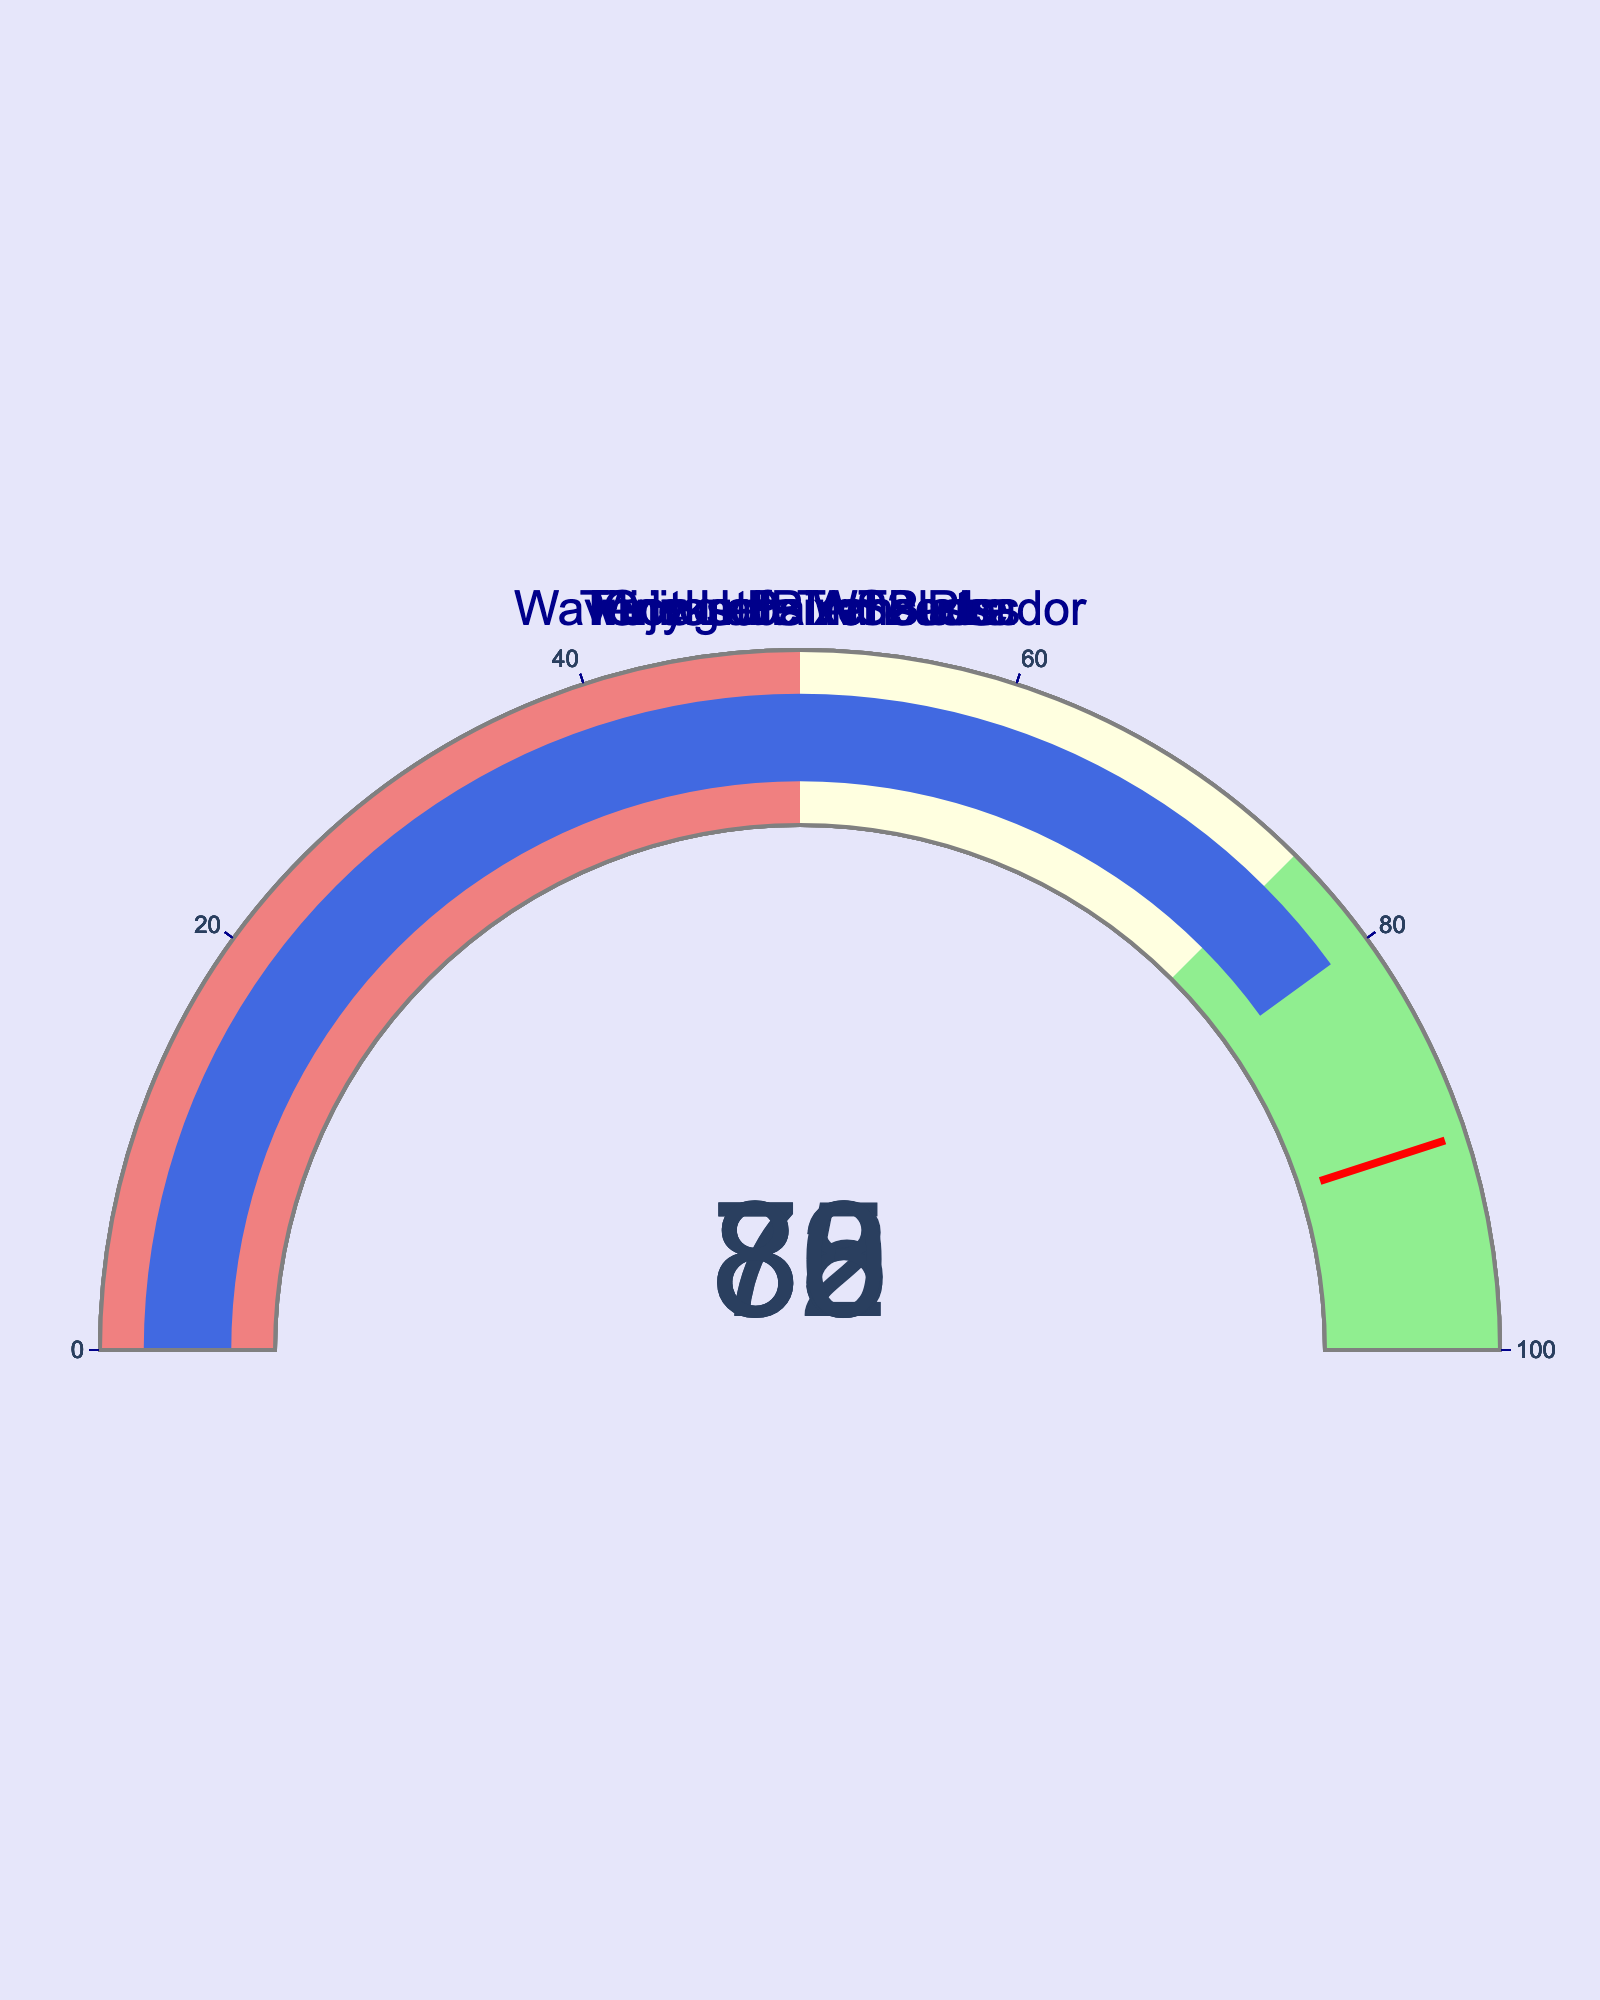How many devices are shown on the gauge charts? There are separate gauges displayed for each device's accuracy rate. By counting them, we find that there are five devices presented.
Answer: Five What is the accuracy rate of the Google Pixel Buds device? Look at the value displayed on the gauge chart for the Google Pixel Buds. The value reads 78.
Answer: 78 Which device shows the highest accuracy rate? Compare the values on all five gauge charts. The highest number is associated with the Fujitsu PalmSecure device, which has a rate of 85.
Answer: Fujitsu PalmSecure Which two devices have an accuracy rate that falls within the light green step range (75-100)? Identify the devices with accuracy values between 75 and 100. These values are highlighted by the light green step range on the gauge. Two devices meet this criterion: Fujitsu PalmSecure (85) and Microsoft Translator (82).
Answer: Fujitsu PalmSecure and Microsoft Translator What is the average accuracy rate of all the devices in the figure? Sum the accuracy rates of all the devices and then divide by the number of devices: (85 + 78 + 82 + 73 + 80) = 398. Dividing by 5 gives 398/5 = 79.6.
Answer: 79.6 What is the difference between the accuracy rates of the Timekettle WT2 Plus and the Waverly Labs Ambassador? Subtract the accuracy rate of Waverly Labs Ambassador (73) from the accuracy rate of Timekettle WT2 Plus (80). The calculation is 80 - 73 = 7.
Answer: 7 Which device has the lowest accuracy rate, and what is the value? Find the device with the smallest value on the gauge charts. The Waverly Labs Ambassador has the lowest accuracy rate, which is 73.
Answer: Waverly Labs Ambassador, 73 Are there any devices with an accuracy rate below 75? If so, which ones? Look for gauges with values less than 75. The Waverly Labs Ambassador has an accuracy rate of 73, which is below 75.
Answer: Waverly Labs Ambassador What is the combined accuracy rate of the devices with accuracy rates above 80? Identify devices with accuracy rates above 80: Fujitsu PalmSecure (85) and Microsoft Translator (82). Add their accuracy rates: 85 + 82 = 167.
Answer: 167 